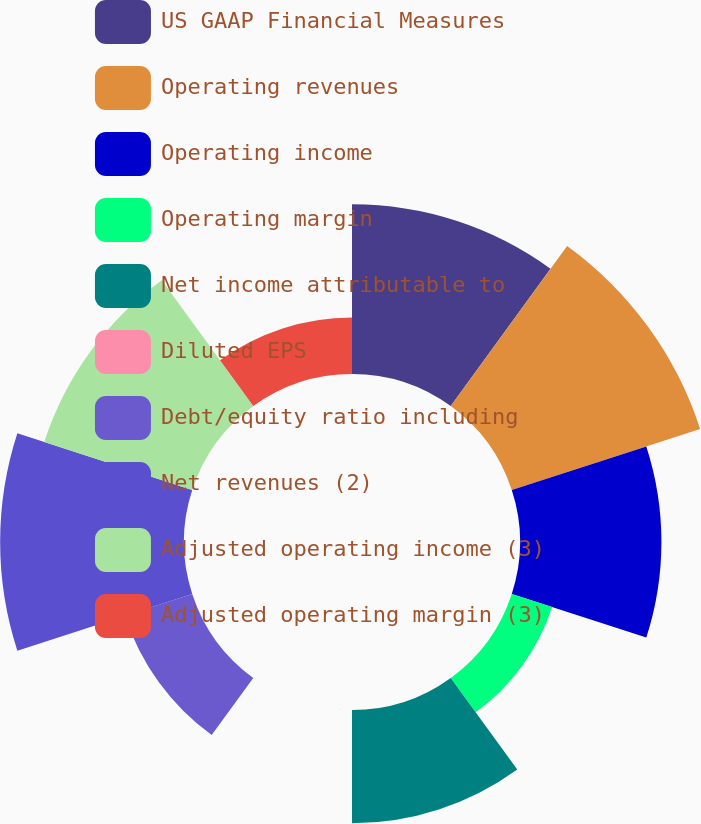<chart> <loc_0><loc_0><loc_500><loc_500><pie_chart><fcel>US GAAP Financial Measures<fcel>Operating revenues<fcel>Operating income<fcel>Operating margin<fcel>Net income attributable to<fcel>Diluted EPS<fcel>Debt/equity ratio including<fcel>Net revenues (2)<fcel>Adjusted operating income (3)<fcel>Adjusted operating margin (3)<nl><fcel>15.0%<fcel>17.5%<fcel>12.5%<fcel>3.75%<fcel>10.0%<fcel>0.01%<fcel>6.25%<fcel>16.25%<fcel>13.75%<fcel>5.0%<nl></chart> 